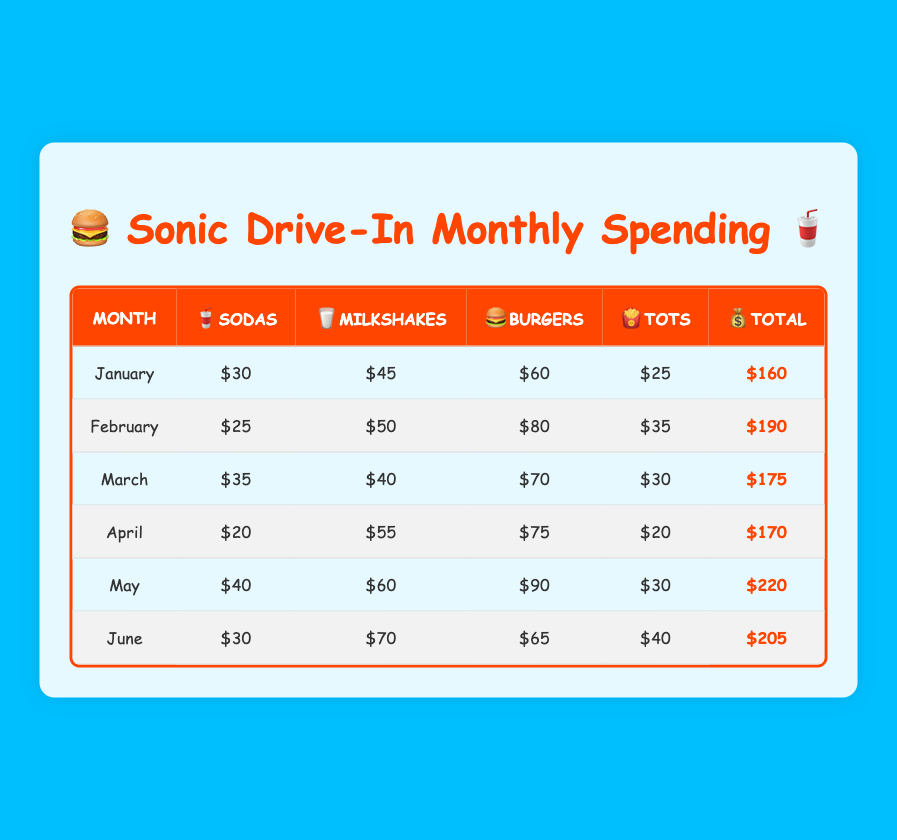What is the total spending for May? The total spending for May is listed in the table under the "Total" column for that month. It reads $220.
Answer: 220 Which month had the highest spending on burgers? The month with the highest spending on burgers can be found by looking at the values in the "Burgers" column. The highest value is $90 in May.
Answer: May What is the average spending on sodas from January to June? To find the average spending on sodas, we sum the values from January to June: (30 + 25 + 35 + 20 + 40 + 30) = 180. Then we divide by the number of months, which is 6. So, the average is 180 / 6 = 30.
Answer: 30 Did April have a higher total spending than March? To determine this, we compare the total spending for April, which is $170, and March, which is $175. Since $170 is less than $175, the answer is no.
Answer: No What are the total expenditures on milkshakes from January to April? We sum the expenditures for milkshakes from January to April: (45 + 50 + 40 + 55) = 190.
Answer: 190 Which month had the least spending on tots? The month with the least spending on tots is the one with the lowest value in the "Tots" column. The lowest value is $20 in April.
Answer: April If I wanted to know the total spending for the first quarter (January, February, March), how much would that be? We add the total spending for January, February, and March: $160 (January) + $190 (February) + $175 (March) = $525.
Answer: 525 Was there an increase in total spending from February to March? To answer this, we look at the total spending values for February ($190) and March ($175). Since $175 is less than $190, there was a decrease, so the answer is no.
Answer: No 